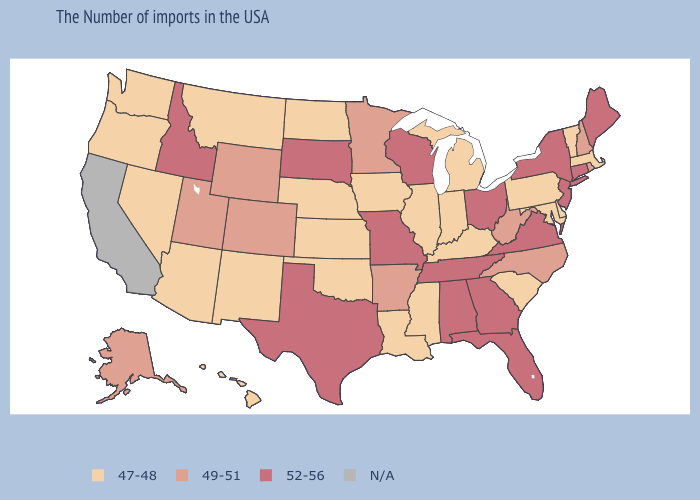Which states have the lowest value in the USA?
Give a very brief answer. Massachusetts, Vermont, Delaware, Maryland, Pennsylvania, South Carolina, Michigan, Kentucky, Indiana, Illinois, Mississippi, Louisiana, Iowa, Kansas, Nebraska, Oklahoma, North Dakota, New Mexico, Montana, Arizona, Nevada, Washington, Oregon, Hawaii. Does the first symbol in the legend represent the smallest category?
Answer briefly. Yes. Among the states that border Pennsylvania , does Ohio have the highest value?
Concise answer only. Yes. What is the value of Massachusetts?
Answer briefly. 47-48. Name the states that have a value in the range 47-48?
Give a very brief answer. Massachusetts, Vermont, Delaware, Maryland, Pennsylvania, South Carolina, Michigan, Kentucky, Indiana, Illinois, Mississippi, Louisiana, Iowa, Kansas, Nebraska, Oklahoma, North Dakota, New Mexico, Montana, Arizona, Nevada, Washington, Oregon, Hawaii. Does Illinois have the highest value in the USA?
Concise answer only. No. What is the value of Alabama?
Quick response, please. 52-56. What is the value of Wyoming?
Give a very brief answer. 49-51. Which states have the lowest value in the USA?
Answer briefly. Massachusetts, Vermont, Delaware, Maryland, Pennsylvania, South Carolina, Michigan, Kentucky, Indiana, Illinois, Mississippi, Louisiana, Iowa, Kansas, Nebraska, Oklahoma, North Dakota, New Mexico, Montana, Arizona, Nevada, Washington, Oregon, Hawaii. Does Iowa have the lowest value in the USA?
Give a very brief answer. Yes. Name the states that have a value in the range 52-56?
Answer briefly. Maine, Connecticut, New York, New Jersey, Virginia, Ohio, Florida, Georgia, Alabama, Tennessee, Wisconsin, Missouri, Texas, South Dakota, Idaho. Among the states that border Montana , does Wyoming have the lowest value?
Short answer required. No. What is the value of Michigan?
Concise answer only. 47-48. 